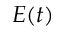Convert formula to latex. <formula><loc_0><loc_0><loc_500><loc_500>E ( t )</formula> 